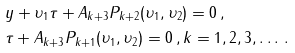<formula> <loc_0><loc_0><loc_500><loc_500>& { y } + { \upsilon _ { 1 } } { \tau } + A _ { k + 3 } P _ { k + 2 } ( { \upsilon _ { 1 } } , { \upsilon _ { 2 } } ) = 0 \, , \\ & { \tau } + A _ { k + 3 } P _ { k + 1 } ( { \upsilon _ { 1 } } , { \upsilon _ { 2 } } ) = 0 \, , k = 1 , 2 , 3 , \dots \, .</formula> 